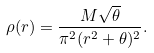Convert formula to latex. <formula><loc_0><loc_0><loc_500><loc_500>\rho ( r ) = \frac { M \sqrt { \theta } } { \pi ^ { 2 } ( r ^ { 2 } + \theta ) ^ { 2 } } .</formula> 